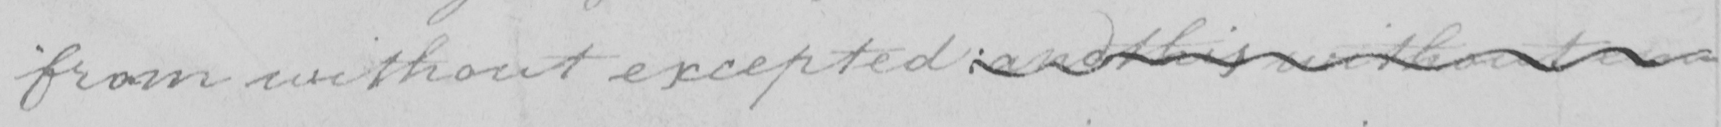Can you read and transcribe this handwriting? from without excepted :  and this without em- 